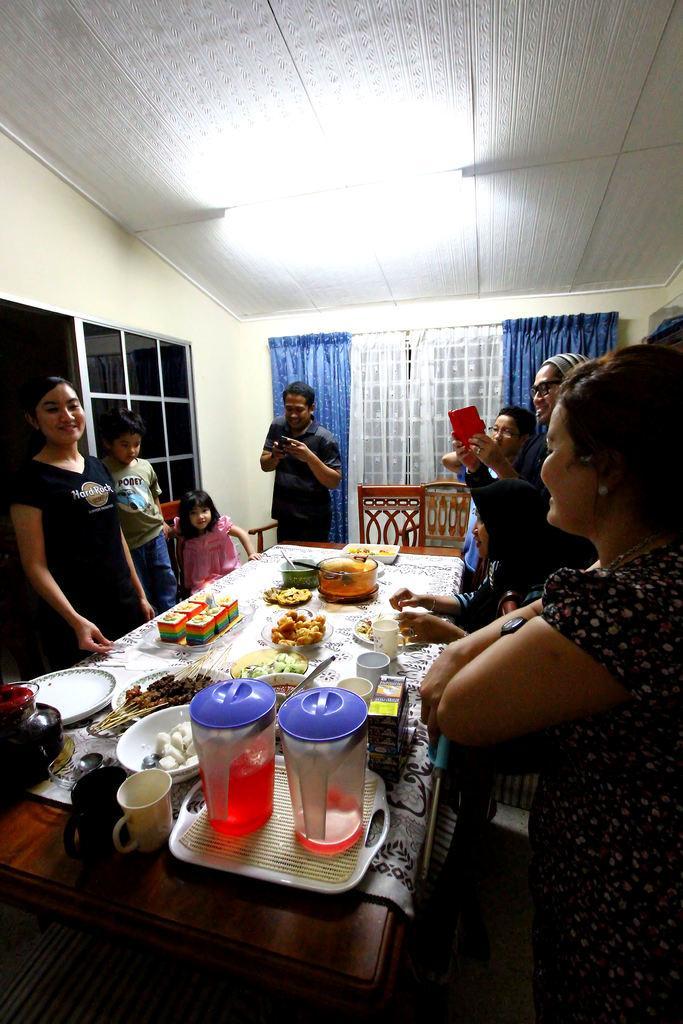How would you summarize this image in a sentence or two? In this image i can see a group of people standing around the dining table and on the table i can see a tray, 2 jars few food items and few bowls. In the background i can see the roof, a light, the curtains and the wall. 